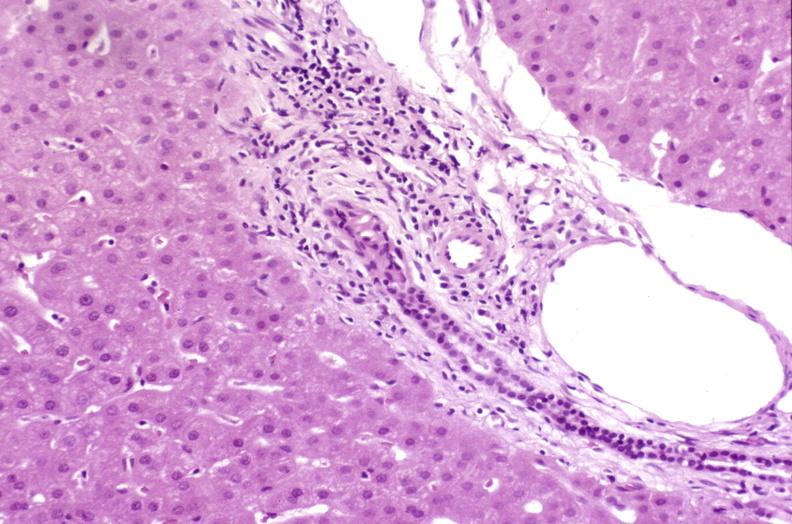what is present?
Answer the question using a single word or phrase. Liver 